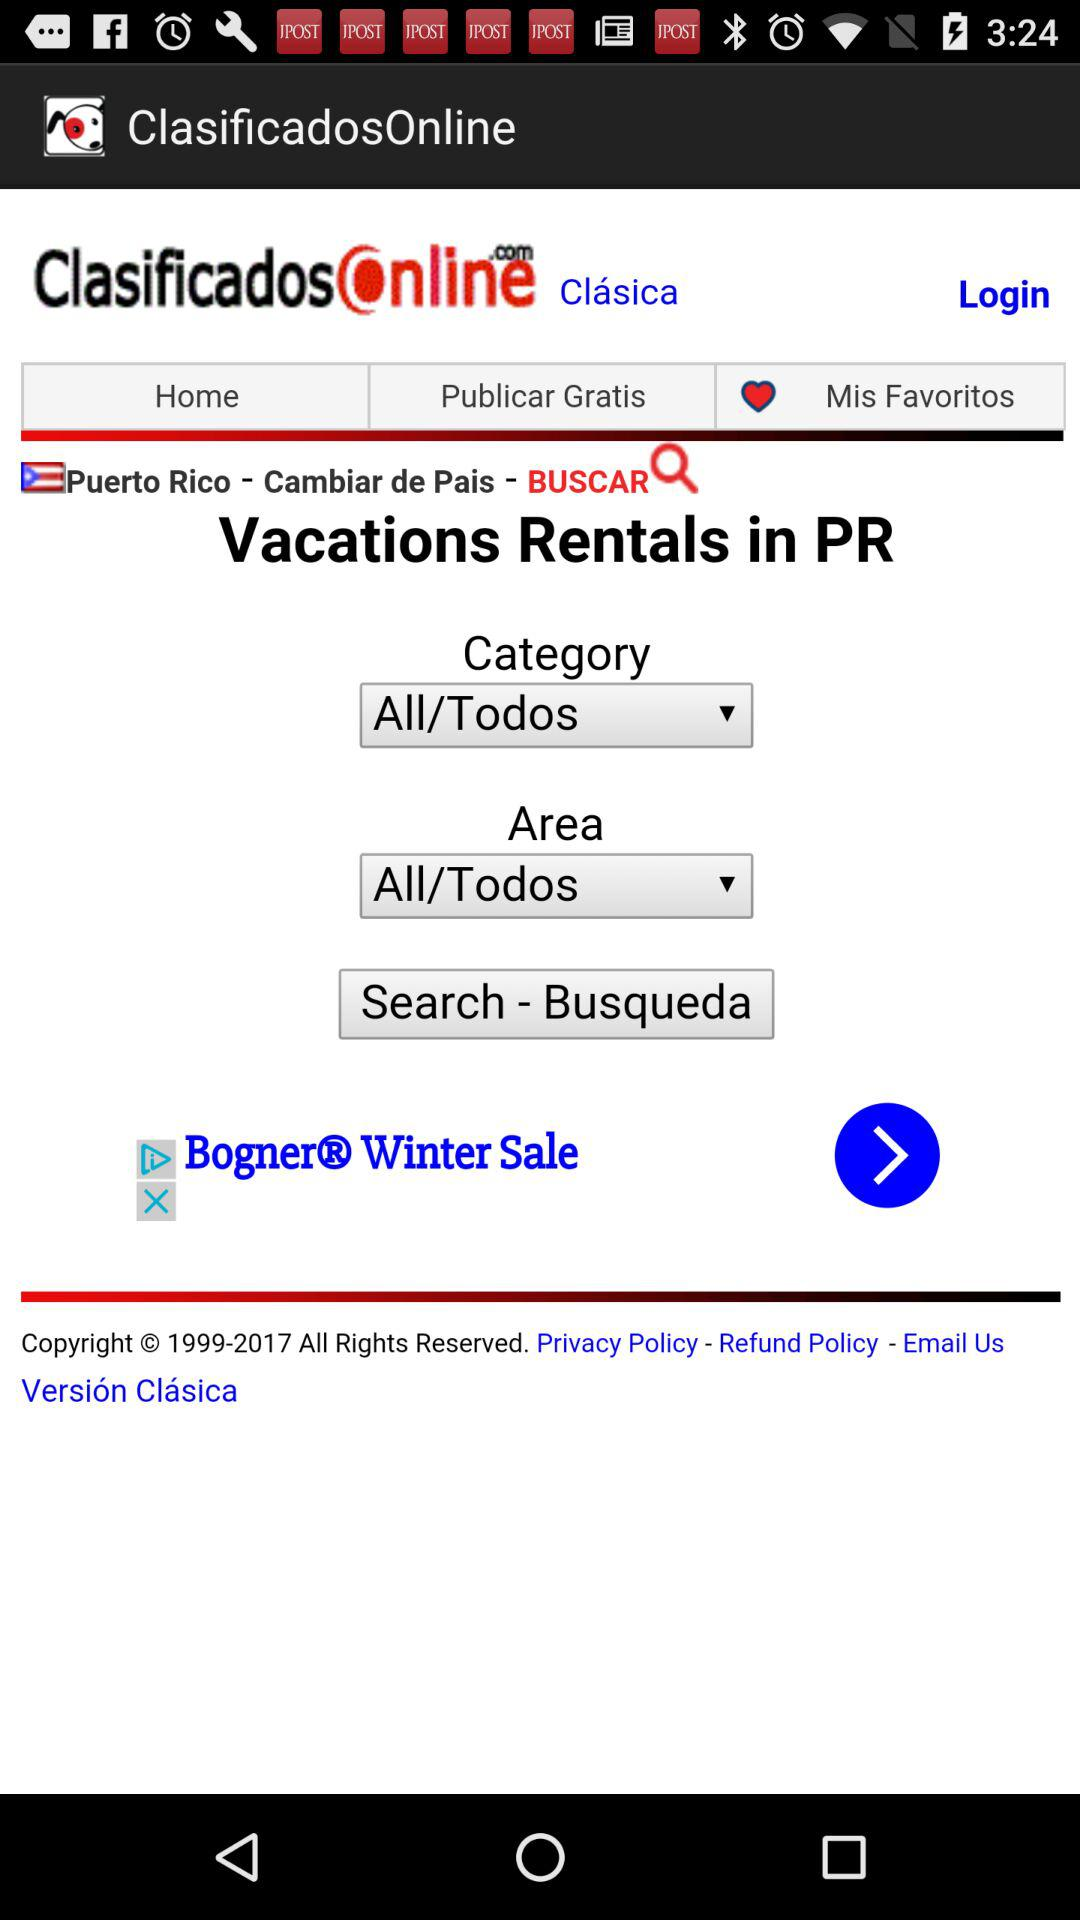Which option has been selected in "Category"? The selected option is "All/Todos". 